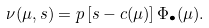<formula> <loc_0><loc_0><loc_500><loc_500>\nu ( \mu , s ) = p \left [ s - c ( \mu ) \right ] \Phi _ { \bullet } ( \mu ) .</formula> 